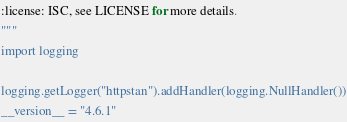Convert code to text. <code><loc_0><loc_0><loc_500><loc_500><_Python_>
:license: ISC, see LICENSE for more details.
"""
import logging

logging.getLogger("httpstan").addHandler(logging.NullHandler())
__version__ = "4.6.1"
</code> 